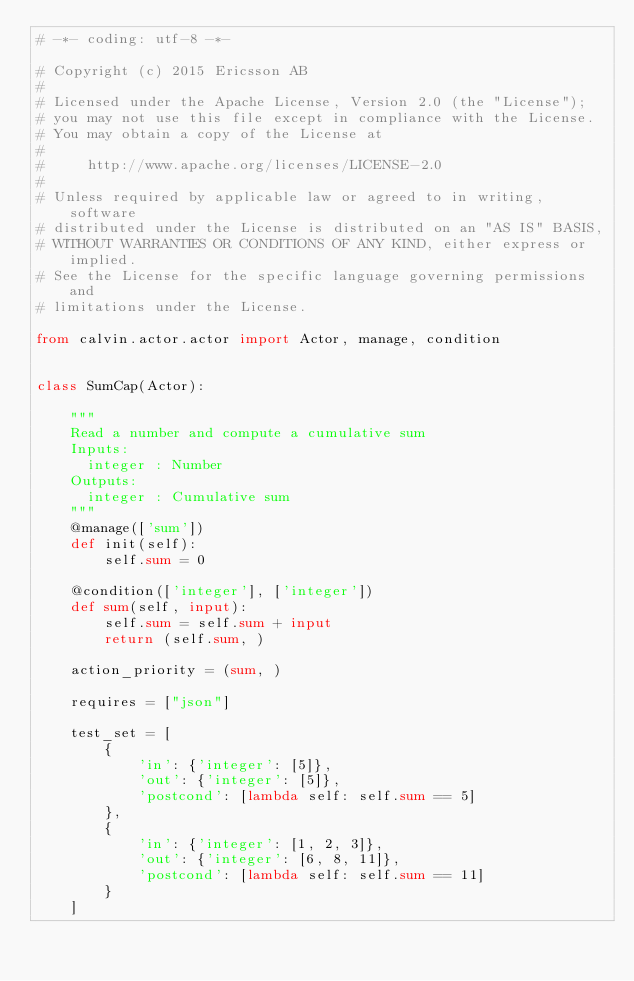Convert code to text. <code><loc_0><loc_0><loc_500><loc_500><_Python_># -*- coding: utf-8 -*-

# Copyright (c) 2015 Ericsson AB
#
# Licensed under the Apache License, Version 2.0 (the "License");
# you may not use this file except in compliance with the License.
# You may obtain a copy of the License at
#
#     http://www.apache.org/licenses/LICENSE-2.0
#
# Unless required by applicable law or agreed to in writing, software
# distributed under the License is distributed on an "AS IS" BASIS,
# WITHOUT WARRANTIES OR CONDITIONS OF ANY KIND, either express or implied.
# See the License for the specific language governing permissions and
# limitations under the License.

from calvin.actor.actor import Actor, manage, condition


class SumCap(Actor):

    """
    Read a number and compute a cumulative sum
    Inputs:
      integer : Number
    Outputs:
      integer : Cumulative sum
    """
    @manage(['sum'])
    def init(self):
        self.sum = 0

    @condition(['integer'], ['integer'])
    def sum(self, input):
        self.sum = self.sum + input
        return (self.sum, )

    action_priority = (sum, )

    requires = ["json"]

    test_set = [
        {
            'in': {'integer': [5]},
            'out': {'integer': [5]},
            'postcond': [lambda self: self.sum == 5]
        },
        {
            'in': {'integer': [1, 2, 3]},
            'out': {'integer': [6, 8, 11]},
            'postcond': [lambda self: self.sum == 11]
        }
    ]
</code> 